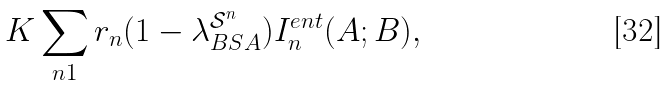<formula> <loc_0><loc_0><loc_500><loc_500>K \sum _ { n 1 } r _ { n } ( 1 - \lambda _ { B S A } ^ { \mathcal { S } ^ { n } } ) I _ { n } ^ { e n t } ( A ; B ) ,</formula> 